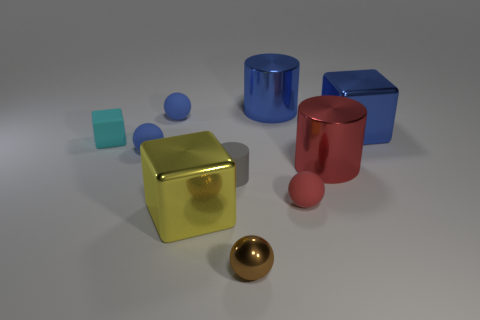There is a rubber cylinder that is the same size as the cyan matte object; what color is it?
Your answer should be compact. Gray. Is there a yellow thing that has the same shape as the small cyan rubber object?
Provide a short and direct response. Yes. The tiny cyan object in front of the block right of the shiny cylinder that is in front of the cyan rubber object is made of what material?
Your answer should be compact. Rubber. How many other objects are the same size as the cyan block?
Offer a terse response. 5. The small rubber cylinder is what color?
Give a very brief answer. Gray. What number of matte things are tiny balls or big blue blocks?
Your answer should be compact. 3. Is there any other thing that is made of the same material as the small red object?
Ensure brevity in your answer.  Yes. There is a blue ball that is in front of the large block that is right of the matte ball that is to the right of the large yellow metallic object; what is its size?
Your response must be concise. Small. There is a object that is both in front of the tiny red rubber object and behind the tiny metal object; what is its size?
Provide a succinct answer. Large. There is a big object that is behind the big blue metallic cube; is it the same color as the metal cube behind the yellow metallic thing?
Make the answer very short. Yes. 